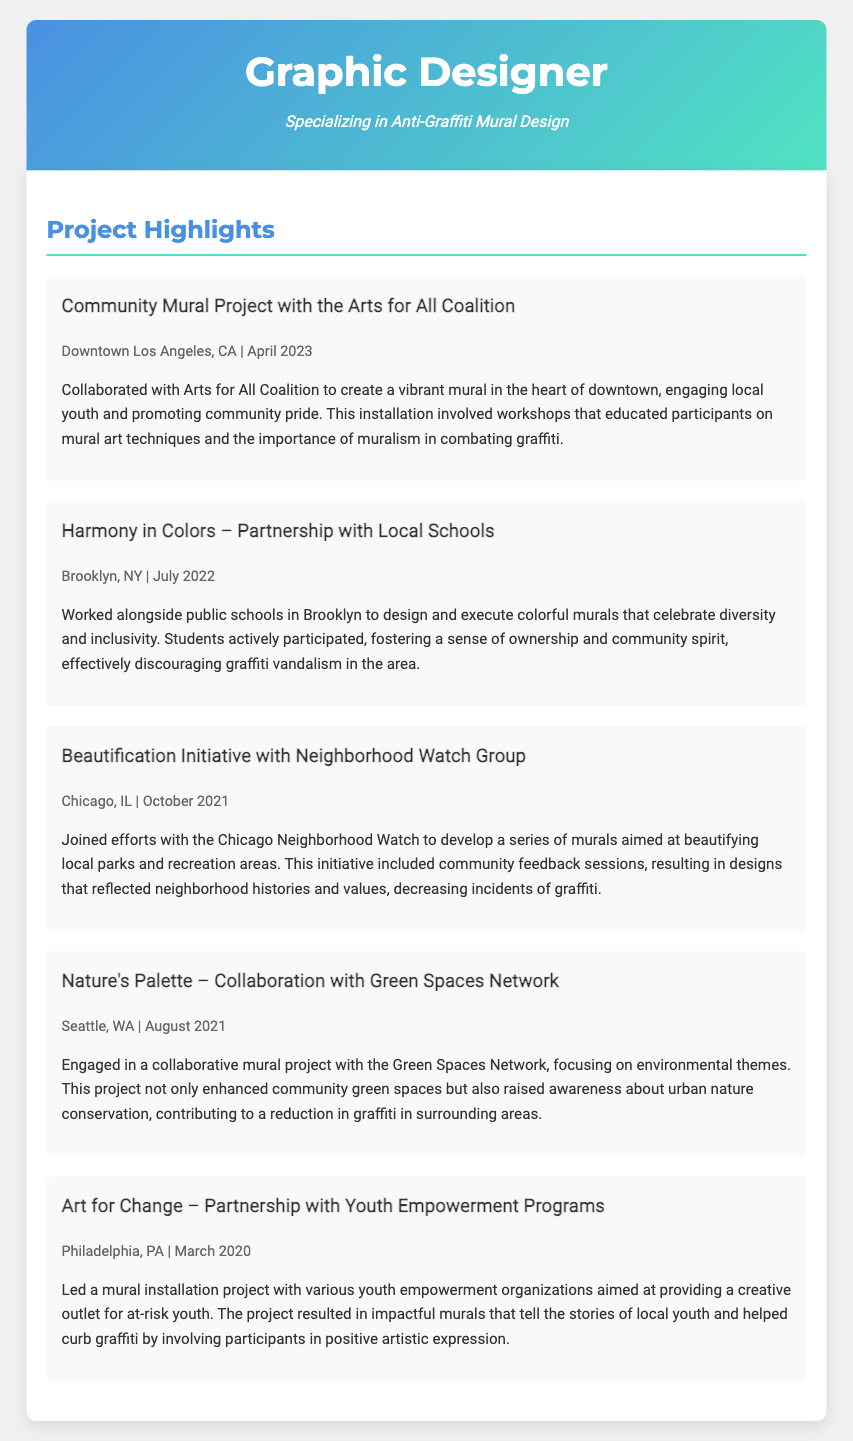What is the title of the first project? The title of the first project mentioned in the document is "Community Mural Project with the Arts for All Coalition".
Answer: Community Mural Project with the Arts for All Coalition In which city did the "Harmony in Colors" project take place? The "Harmony in Colors" project is specified to have occurred in Brooklyn, NY.
Answer: Brooklyn, NY What month and year was the Beautification Initiative completed? The Beautification Initiative took place in October 2021, according to the document.
Answer: October 2021 Which community organization was involved in the "Art for Change" project? The "Art for Change" project was a partnership with various youth empowerment organizations.
Answer: Youth Empowerment Programs How did the "Nature's Palette" project contribute to the community? The "Nature's Palette" project focused on enhancing community green spaces and raising awareness about urban nature conservation.
Answer: Enhancing community green spaces What is a common theme among the mural projects described? A common theme among the mural projects is community engagement and discouraging graffiti vandalism.
Answer: Community engagement and discouraging graffiti vandalism Which project involved workshops for local youth? The project that involved workshops for local youth is the "Community Mural Project with the Arts for All Coalition".
Answer: Community Mural Project with the Arts for All Coalition What was the primary focus of the "Beautification Initiative"? The primary focus of the "Beautification Initiative" was to beautify local parks and recreation areas.
Answer: Beautifying local parks and recreation areas 